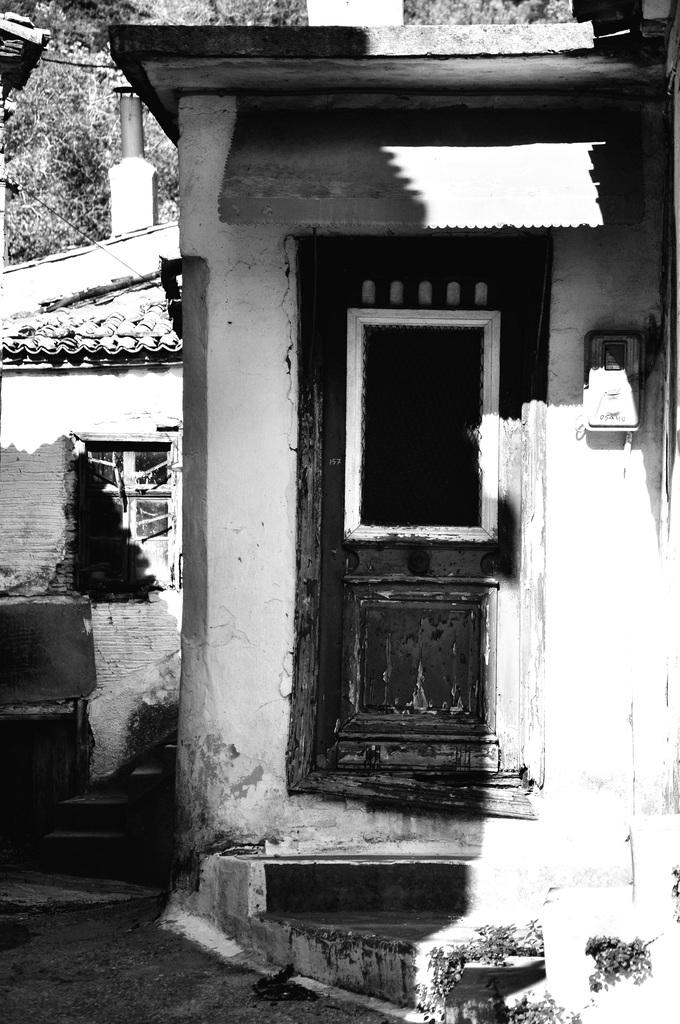What is the main subject in the center of the image? There is a small house in the center of the image. Are there any other houses visible in the image? Yes, there is another house on the left side of the image. What type of vegetation can be seen at the top side of the image? There are trees at the top side of the image. What type of stick can be seen holding up the bun in the image? There is no stick or bun present in the image; it features houses and trees. 